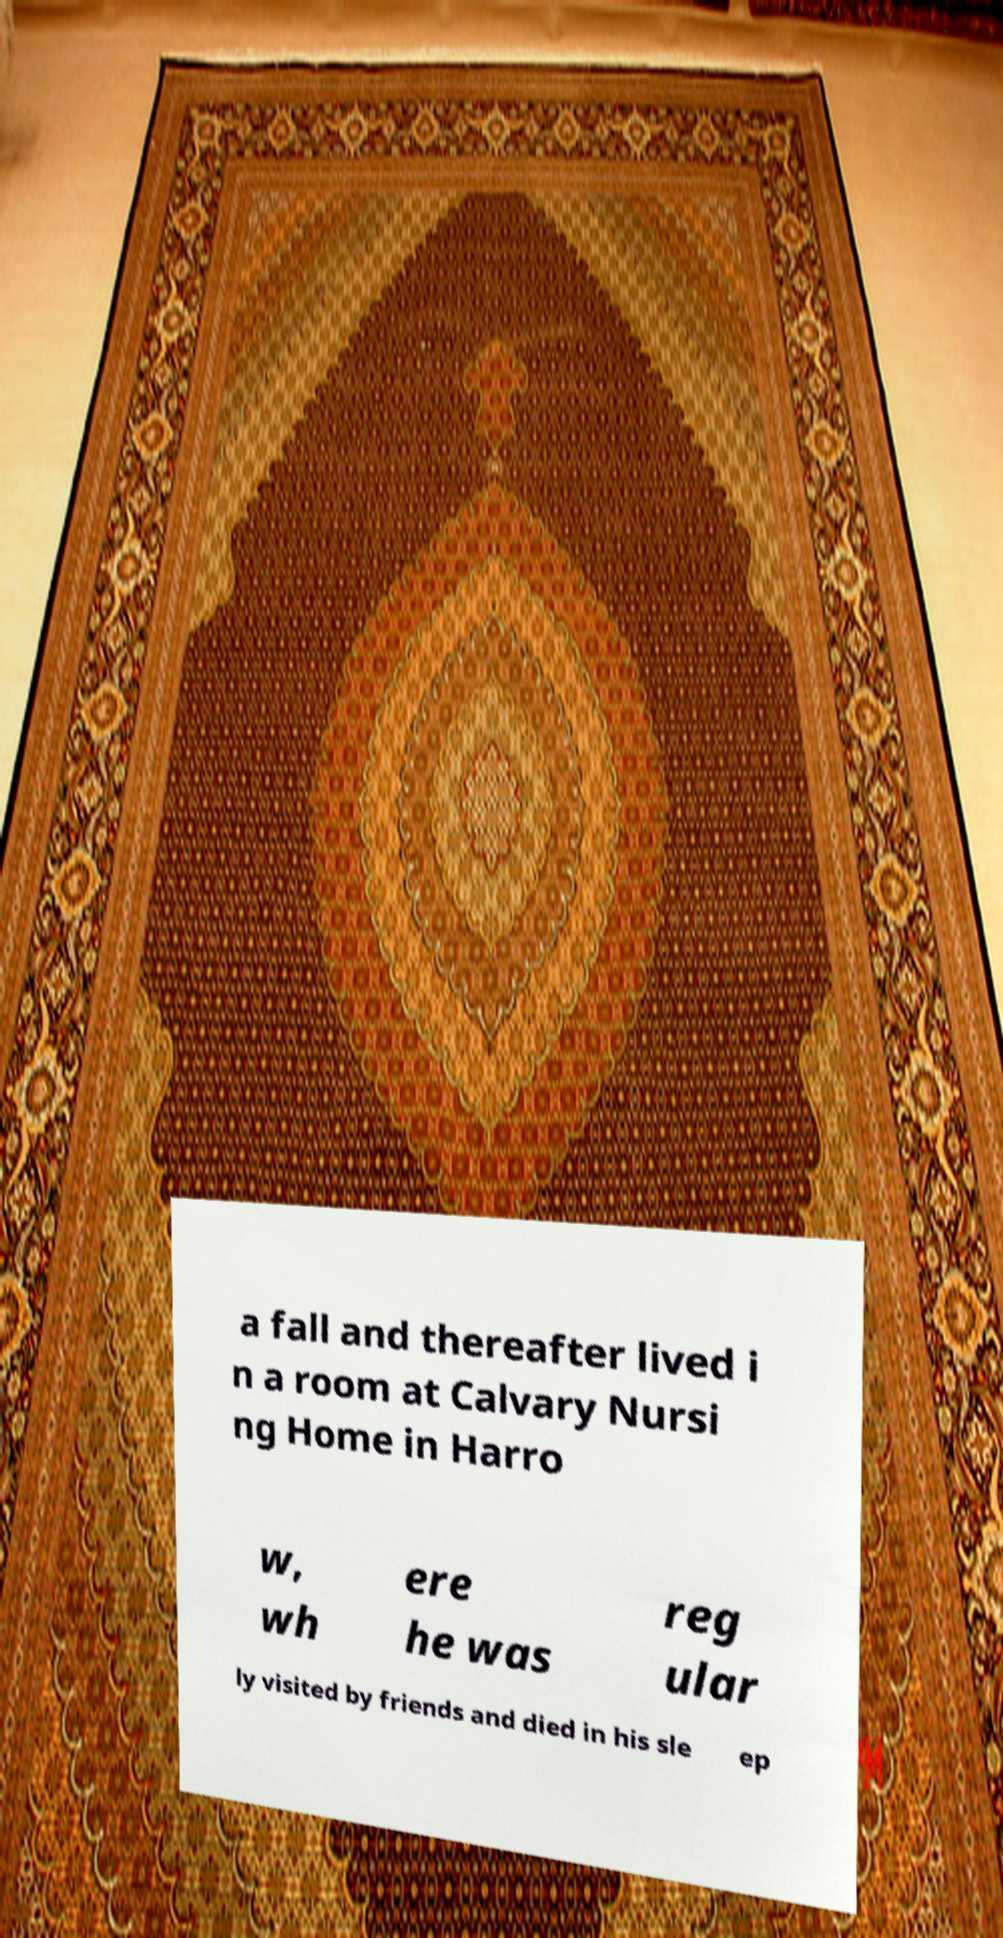What messages or text are displayed in this image? I need them in a readable, typed format. a fall and thereafter lived i n a room at Calvary Nursi ng Home in Harro w, wh ere he was reg ular ly visited by friends and died in his sle ep 